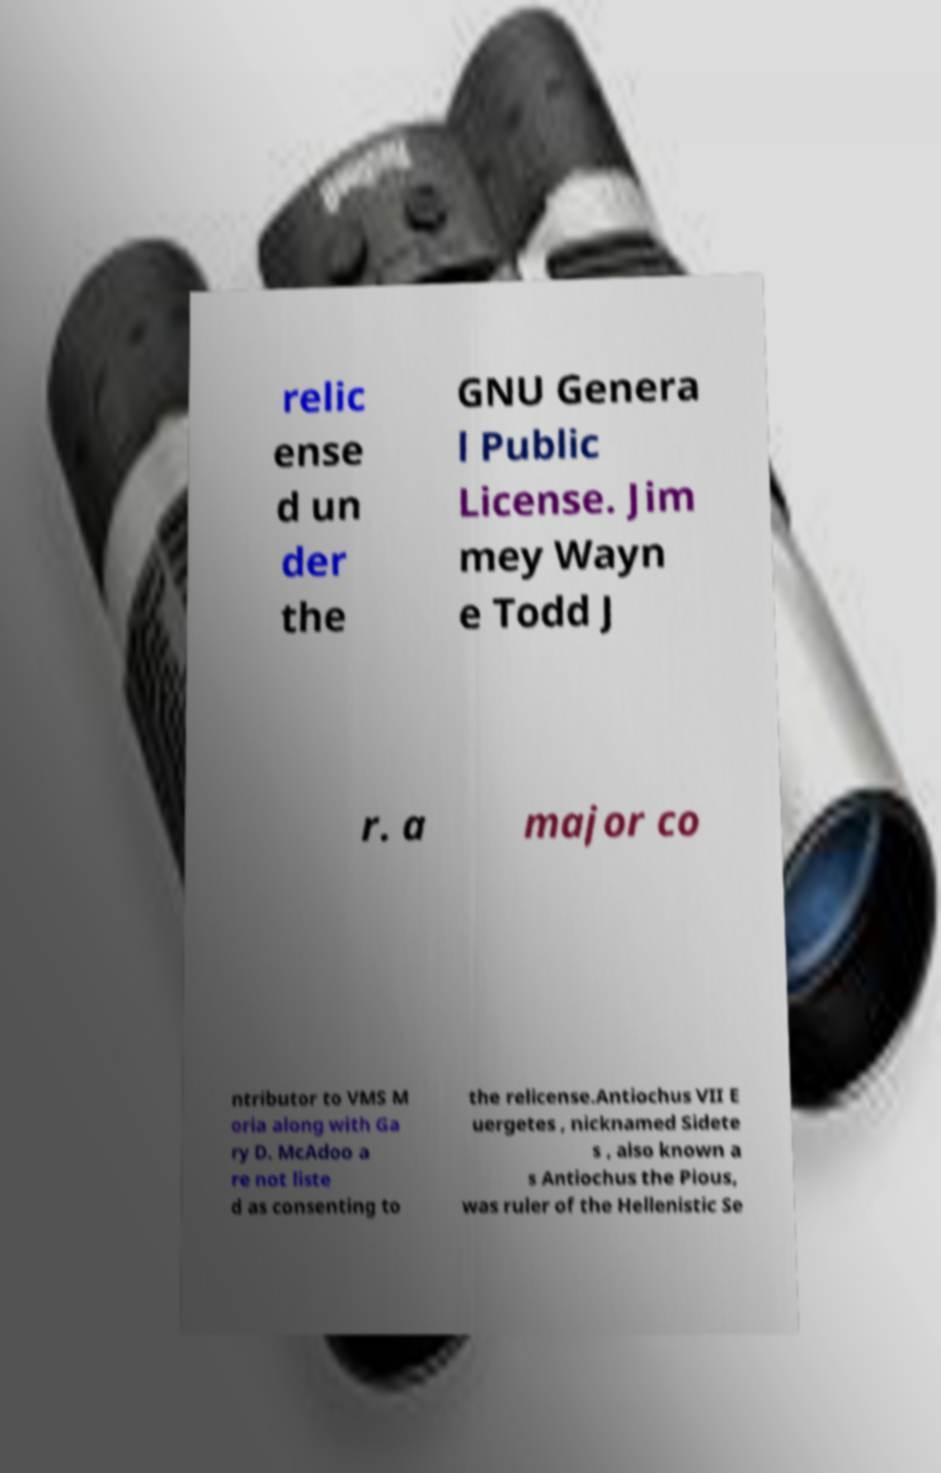There's text embedded in this image that I need extracted. Can you transcribe it verbatim? relic ense d un der the GNU Genera l Public License. Jim mey Wayn e Todd J r. a major co ntributor to VMS M oria along with Ga ry D. McAdoo a re not liste d as consenting to the relicense.Antiochus VII E uergetes , nicknamed Sidete s , also known a s Antiochus the Pious, was ruler of the Hellenistic Se 